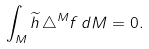<formula> <loc_0><loc_0><loc_500><loc_500>\int _ { M } \widetilde { h } \, \triangle ^ { M } f \, d M = 0 .</formula> 